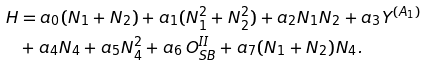<formula> <loc_0><loc_0><loc_500><loc_500>H & = a _ { 0 } ( N _ { 1 } + N _ { 2 } ) + a _ { 1 } ( N _ { 1 } ^ { 2 } + N _ { 2 } ^ { 2 } ) + a _ { 2 } N _ { 1 } N _ { 2 } + a _ { 3 } Y ^ { ( A _ { 1 } ) } \\ & + a _ { 4 } N _ { 4 } + a _ { 5 } N _ { 4 } ^ { 2 } + a _ { 6 } \, O _ { S B } ^ { I I } + a _ { 7 } ( N _ { 1 } + N _ { 2 } ) N _ { 4 } .</formula> 